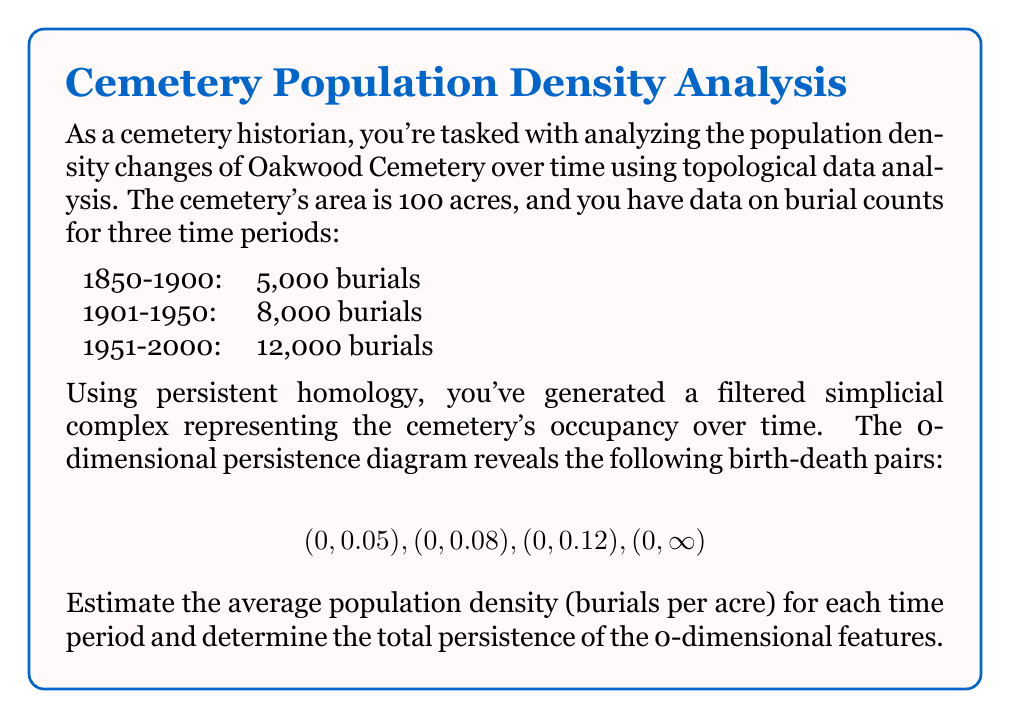Give your solution to this math problem. Let's approach this problem step-by-step:

1) First, we need to calculate the population density for each time period:

   1850-1900: $\frac{5,000 \text{ burials}}{100 \text{ acres}} = 50 \text{ burials/acre}$
   1901-1950: $\frac{8,000 \text{ burials}}{100 \text{ acres}} = 80 \text{ burials/acre}$
   1951-2000: $\frac{12,000 \text{ burials}}{100 \text{ acres}} = 120 \text{ burials/acre}$

2) The persistence diagram gives us information about the topological features of the data. In this case, the birth-death pairs represent when new connected components appear and merge.

3) The birth times (all 0) indicate that all components exist from the beginning. The death times (0.05, 0.08, 0.12, and $\infty$) represent when these components merge or persist indefinitely.

4) We can interpret these values as normalized density thresholds. Multiplying by the maximum density (120 burials/acre) gives us:

   $0.05 \times 120 = 6 \text{ burials/acre}$
   $0.08 \times 120 = 9.6 \text{ burials/acre}$
   $0.12 \times 120 = 14.4 \text{ burials/acre}$

5) These thresholds roughly correspond to the changes in density over time, with the final component persisting indefinitely (representing the cemetery as a whole).

6) To calculate the total persistence, we sum the differences between death and birth times:

   Total Persistence = $(0.05 - 0) + (0.08 - 0) + (0.12 - 0) + (\infty - 0) = 0.25 + \infty$

The finite part (0.25) represents the sum of the finite persistences, while the infinite part represents the overall persistence of the cemetery.
Answer: Average densities: 50, 80, 120 burials/acre. Total persistence: $0.25 + \infty$ 